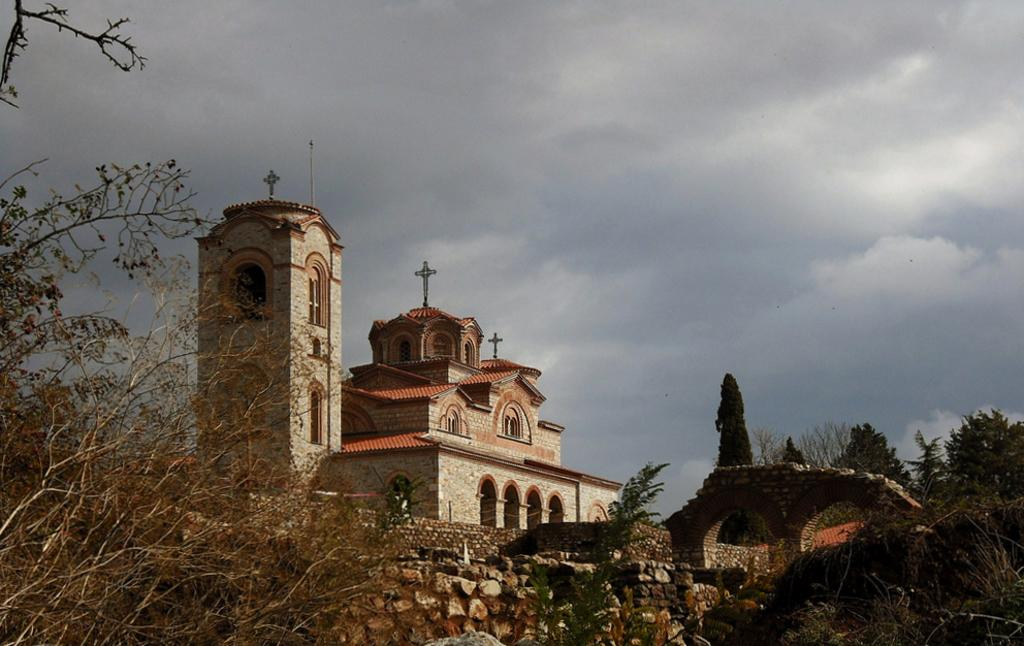What is the condition of the sky in the image? The sky is cloudy in the image. What type of structure can be seen in the image? There is a building with windows in the image. What natural elements are visible in the image? Trees are visible in the image. How does the cloud increase in size in the image? The cloud does not increase in size in the image; it is a static representation of the sky's condition. 